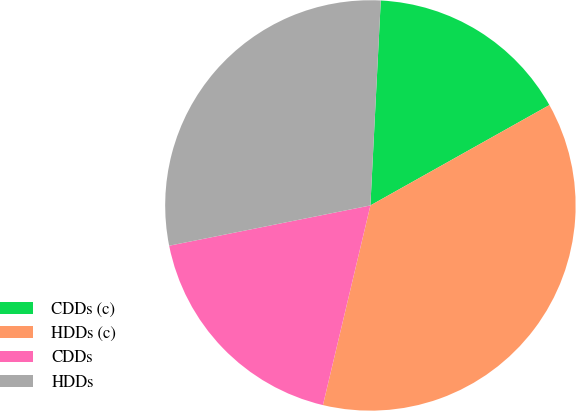Convert chart. <chart><loc_0><loc_0><loc_500><loc_500><pie_chart><fcel>CDDs (c)<fcel>HDDs (c)<fcel>CDDs<fcel>HDDs<nl><fcel>16.06%<fcel>36.85%<fcel>18.14%<fcel>28.95%<nl></chart> 